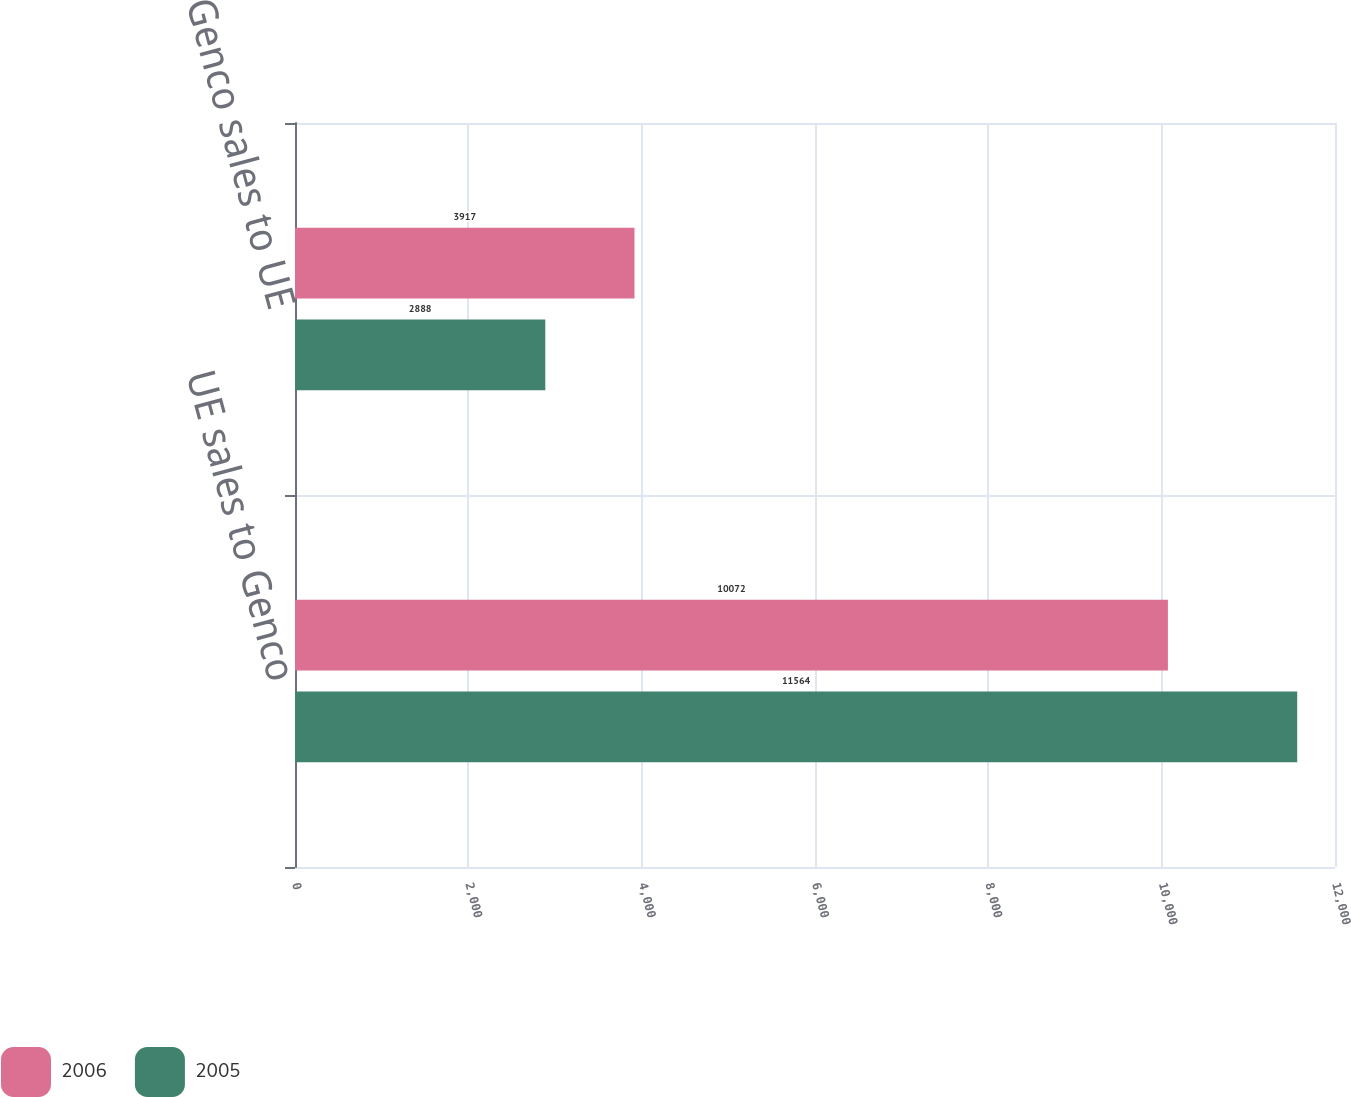Convert chart. <chart><loc_0><loc_0><loc_500><loc_500><stacked_bar_chart><ecel><fcel>UE sales to Genco<fcel>Genco sales to UE<nl><fcel>2006<fcel>10072<fcel>3917<nl><fcel>2005<fcel>11564<fcel>2888<nl></chart> 